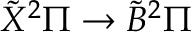<formula> <loc_0><loc_0><loc_500><loc_500>\tilde { X ^ { 2 } \Pi \rightarrow \tilde { B ^ { 2 } \Pi</formula> 